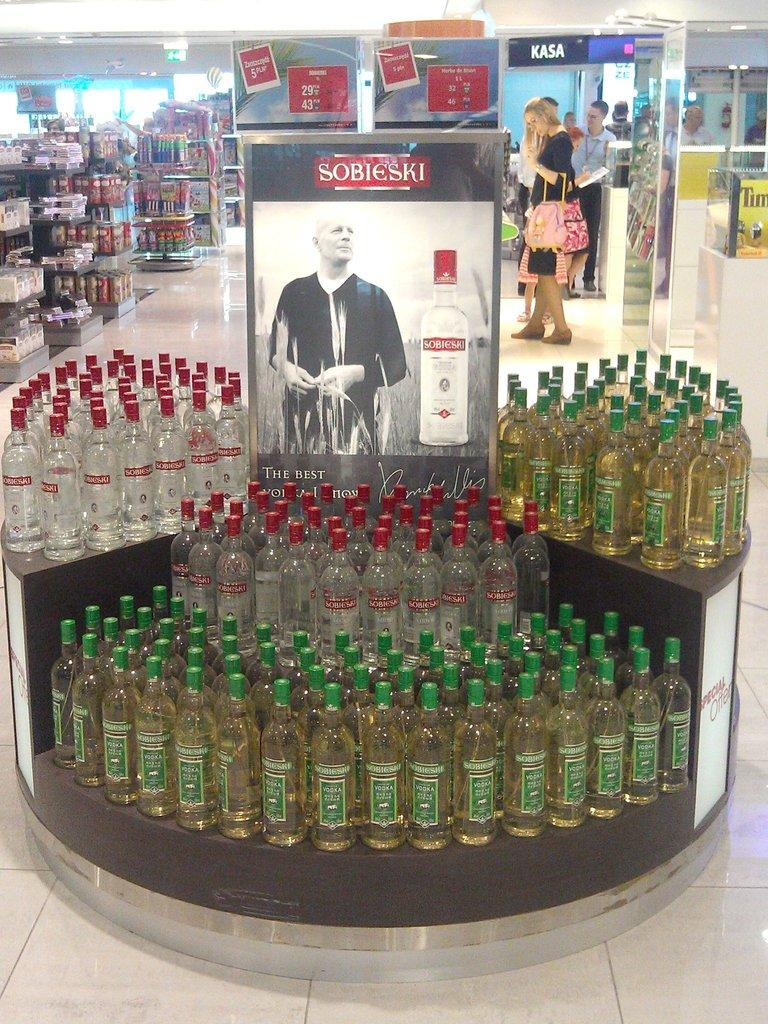Provide a one-sentence caption for the provided image. A large display of Sobieski alcohol is seen in a store. 